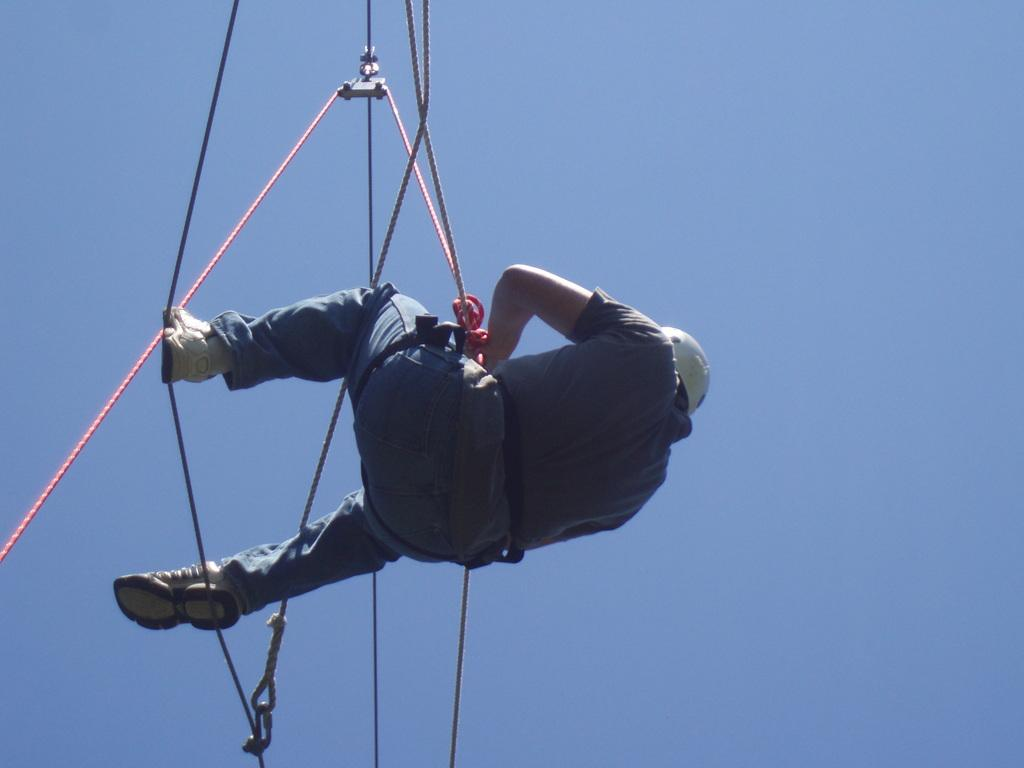What is the main subject of the image? There is a person in the image. What is the person doing in the image? The person is hanging from a rope in the air. What protective gear is the person wearing? The person is wearing a white helmet. What type of footwear is the person wearing? The person is wearing white shoes. What can be seen in the background of the image? The sky is visible in the image. What type of farm animals can be seen in the image? There are no farm animals present in the image; it features a person hanging from a rope in the air. Why is the person crying in the image? There is no indication in the image that the person is crying; they are simply hanging from a rope in the air. 